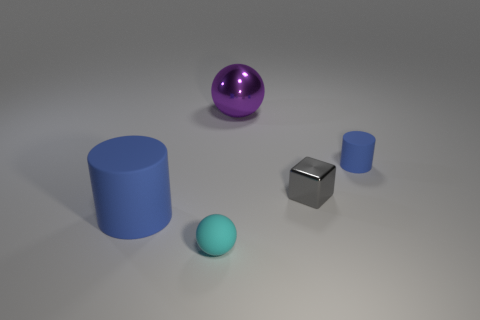Add 2 big cyan cylinders. How many objects exist? 7 Subtract all balls. How many objects are left? 3 Subtract 0 gray cylinders. How many objects are left? 5 Subtract all red rubber cylinders. Subtract all large things. How many objects are left? 3 Add 2 small gray things. How many small gray things are left? 3 Add 4 purple shiny cylinders. How many purple shiny cylinders exist? 4 